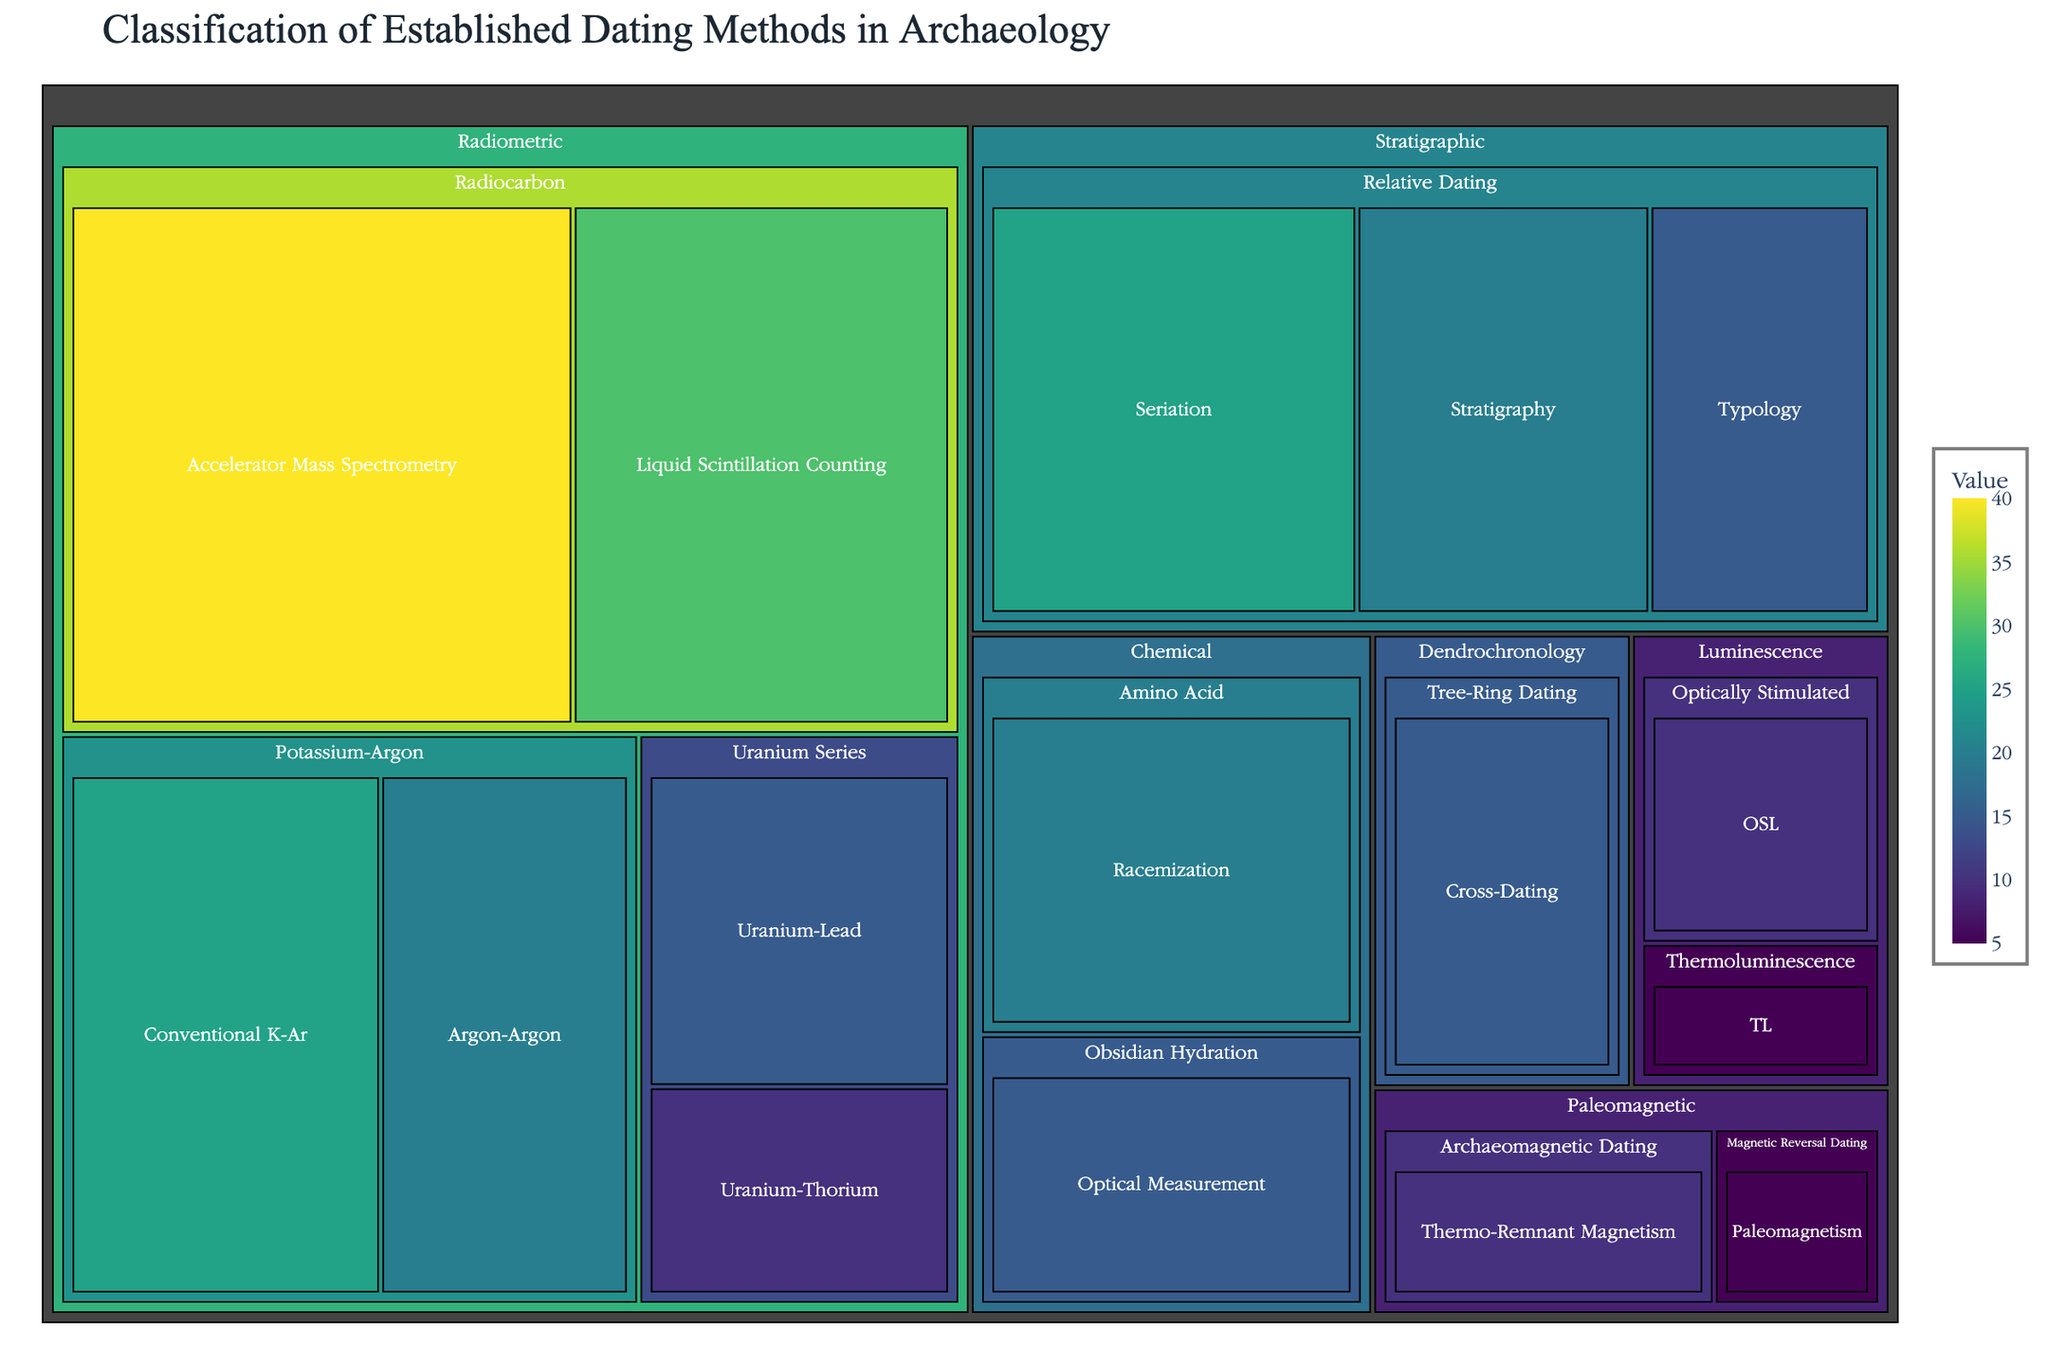What's the title of the figure? The title of the figure is usually displayed prominently at the top. It summarizes the purpose of the figure in a few words. In this case, the title is "Classification of Established Dating Methods in Archaeology."
Answer: Classification of Established Dating Methods in Archaeology Which method has the highest value in the treemap? To find the method with the highest value, look for the largest section within the treemap. The label and value can be identified from the color intensity and size. The largest block belongs to "Accelerator Mass Spectrometry" under "Radiocarbon."
Answer: Accelerator Mass Spectrometry What category contains the method "Thermoluminescence"? Locate "Thermoluminescence" in the treemap and trace the hierarchical path upwards to identify the category it belongs to, which is listed in the dataset as "Luminescence."
Answer: Luminescence What is the sum of values for the Radiometric methods? Identify all values under the "Radiometric" category: 40 (Accelerator Mass Spectrometry) + 30 (Liquid Scintillation Counting) + 25 (Conventional K-Ar) + 20 (Argon-Argon) + 15 (Uranium-Lead) + 10 (Uranium-Thorium). Sum these values to get the total.
Answer: 140 What is the difference in value between “Argon-Argon” and “Thermo-Remnant Magnetism”? Find the values for "Argon-Argon" (20) and "Thermo-Remnant Magnetism" (10). Subtract the latter from the former: 20 - 10.
Answer: 10 Which category has the widest range of method values? Calculate the range for each category by finding the difference between the highest and lowest values within each category. Radiometric: 40 - 10 = 30, Chemical: 20 - 15 = 5, Stratigraphic: 25 - 15 = 10, Paleomagnetic: 10 - 5 = 5, Dendrochronology: 15 only, Luminescence: 10 - 5 = 5. The widest range is for Radiometric.
Answer: Radiometric Within the Stratigraphic category, which method has the lowest value? Look under the "Stratigraphic" category and compare the values of its methods: Seriation (25), Stratigraphy (20), Typology (15). The lowest value is found in "Typology."
Answer: Typology Compare the values of all Optically Stimulated methods. What do you observe? There is only one method under "Optically Stimulated" within "Luminescence," which has a value of 10. Observing a single element means no comparison is necessary among multiple elements.
Answer: Single method with value 10 Which method under Radiocarbon has the least value and what is it? Look under "Radiocarbon" in the "Radiometric" category and compare the values of the methods: Accelerator Mass Spectrometry (40) and Liquid Scintillation Counting (30). The method with the least value is "Liquid Scintillation Counting."
Answer: Liquid Scintillation Counting How does the sum of values for the "Tree-Ring Dating" method compare to the combined values of "Paleomagnetic" methods? Sum the value for "Tree-Ring Dating" method (15) and compare it with the combined values of "Paleomagnetic" methods (10 for Thermo-Remnant Magnetism + 5 for Paleomagnetism = 15). Both sums are equal to 15.
Answer: Equal, both are 15 